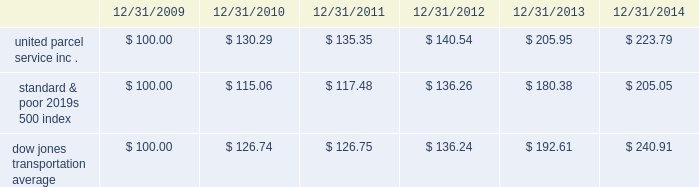Shareowner return performance graph the following performance graph and related information shall not be deemed 201csoliciting material 201d or to be 201cfiled 201d with the sec , nor shall such information be incorporated by reference into any future filing under the securities act of 1933 or securities exchange act of 1934 , each as amended , except to the extent that the company specifically incorporates such information by reference into such filing .
The following graph shows a five year comparison of cumulative total shareowners 2019 returns for our class b common stock , the standard & poor 2019s 500 index , and the dow jones transportation average .
The comparison of the total cumulative return on investment , which is the change in the quarterly stock price plus reinvested dividends for each of the quarterly periods , assumes that $ 100 was invested on december 31 , 2009 in the standard & poor 2019s 500 index , the dow jones transportation average , and our class b common stock. .

What was the difference in percentage cumulative total shareowners 2019 returns for united parcel service inc . compared to the standard & poor's 500 index for the five years ended 12/31/2014? 
Computations: (((223.79 - 100) / 100) - ((205.05 - 100) / 100))
Answer: 0.1874. 